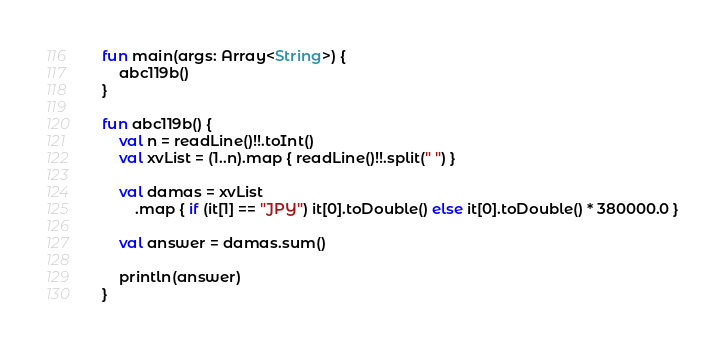Convert code to text. <code><loc_0><loc_0><loc_500><loc_500><_Kotlin_>fun main(args: Array<String>) {
    abc119b()
}

fun abc119b() {
    val n = readLine()!!.toInt()
    val xvList = (1..n).map { readLine()!!.split(" ") }

    val damas = xvList
        .map { if (it[1] == "JPY") it[0].toDouble() else it[0].toDouble() * 380000.0 }

    val answer = damas.sum()

    println(answer)
}
</code> 